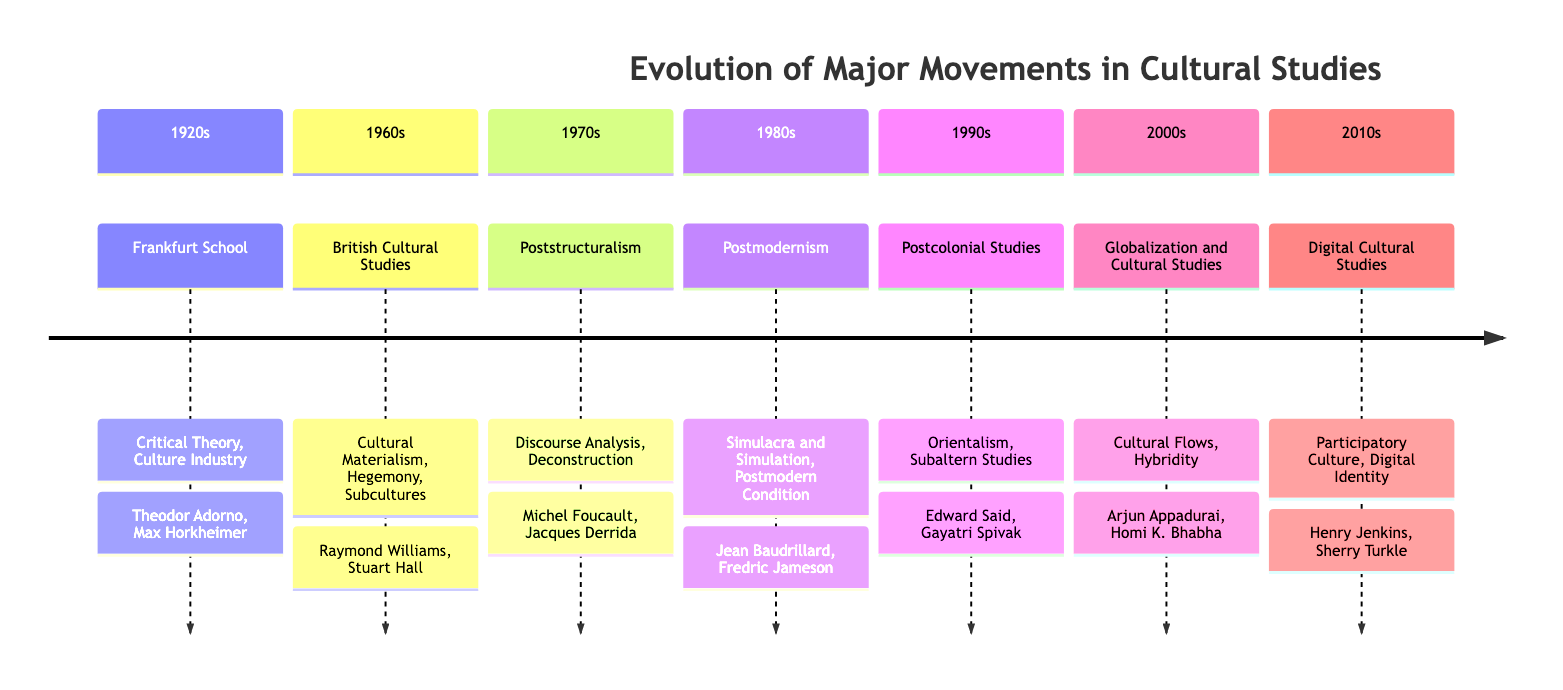What movement is associated with the 1920s? The diagram indicates that the "Frankfurt School" is the movement corresponding to the 1920s.
Answer: Frankfurt School Who are the key figures of British Cultural Studies? According to the diagram, the key figures of British Cultural Studies in the 1960s are "Raymond Williams" and "Stuart Hall."
Answer: Raymond Williams, Stuart Hall What main idea is linked with Postcolonial Studies? The diagram shows that "Orientalism" is one of the main ideas connected with Postcolonial Studies in the 1990s.
Answer: Orientalism In which decade did Postmodernism emerge? The timeline indicates that Postmodernism emerged in the 1980s.
Answer: 1980s Which movement is identified for the 2000s? The diagram states that the movement for the 2000s is "Globalization and Cultural Studies."
Answer: Globalization and Cultural Studies How many key figures are associated with Digital Cultural Studies? The timeline reveals that there are two key figures associated with Digital Cultural Studies in the 2010s: "Henry Jenkins" and "Sherry Turkle."
Answer: 2 What is the last movement listed in the timeline? According to the timeline, the last movement listed is "Digital Cultural Studies" from the 2010s.
Answer: Digital Cultural Studies Which two movements focus on critical analysis of culture? By analyzing the diagram, both the "Frankfurt School" (1920s) and "Poststructuralism" (1970s) movements emphasize critical analysis of culture.
Answer: Frankfurt School, Poststructuralism What is the concept of "Cultural Flows" associated with? The diagram shows that "Cultural Flows" is a main idea linked to the "Globalization and Cultural Studies" movement in the 2000s.
Answer: Globalization and Cultural Studies 